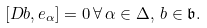Convert formula to latex. <formula><loc_0><loc_0><loc_500><loc_500>[ D b , e _ { \alpha } ] = 0 \, \forall \, \alpha \in \Delta , \, b \in \mathfrak { b } .</formula> 